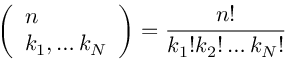Convert formula to latex. <formula><loc_0><loc_0><loc_500><loc_500>\left ( \begin{array} { l } { n } \\ { k _ { 1 } , \dots k _ { N } } \end{array} \right ) = \frac { n ! } { k _ { 1 } ! k _ { 2 } ! \dots k _ { N } ! }</formula> 